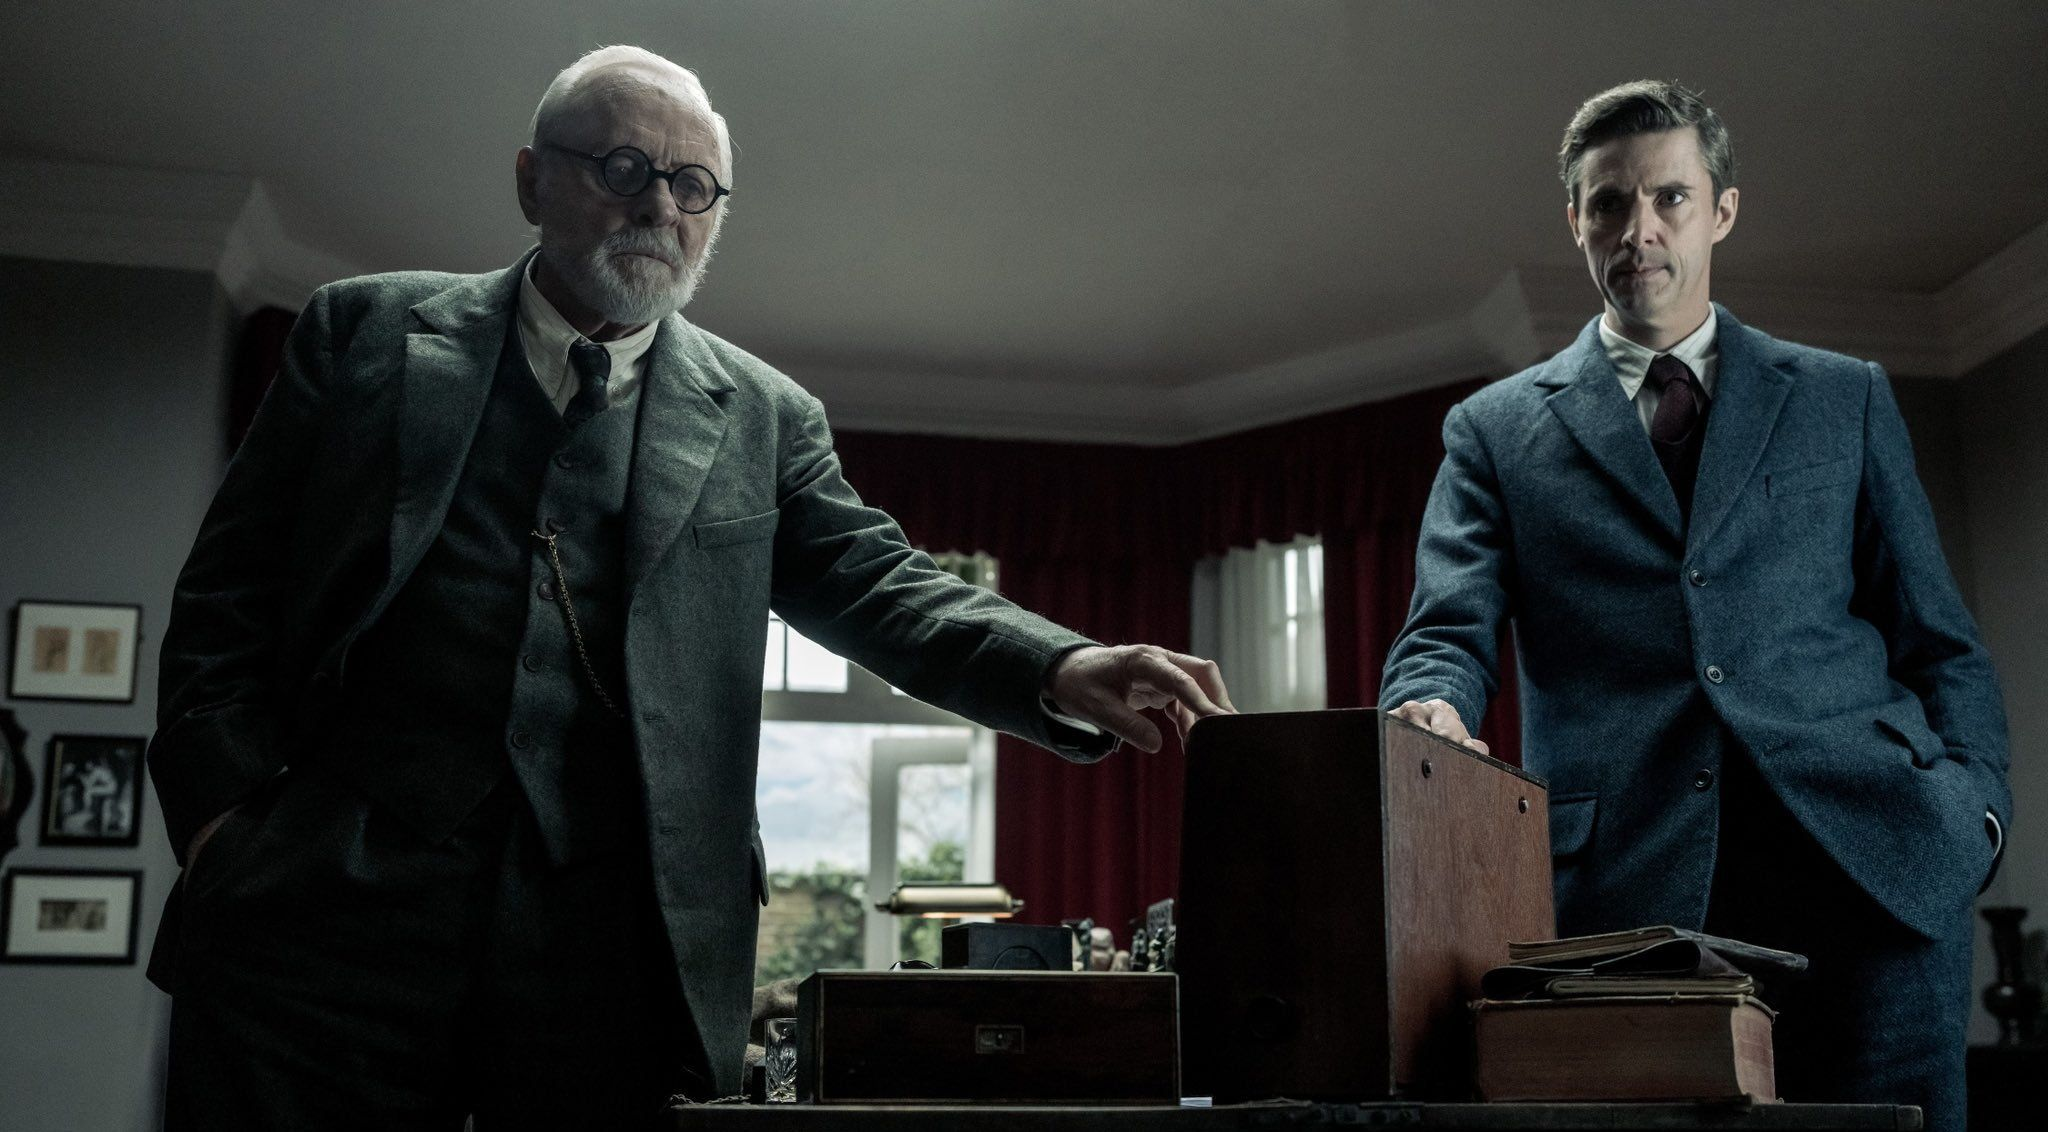Could this scene be taking place in a historical context? Yes, this scene could easily be placed in a historical context. The style of their clothing and the decor of the room suggest a period setting, possibly in the early to mid-20th century. The box could contain wartime secrets or intelligence documents, with the elderly man being an experienced intelligence officer and the younger man a young recruit or a spy. 